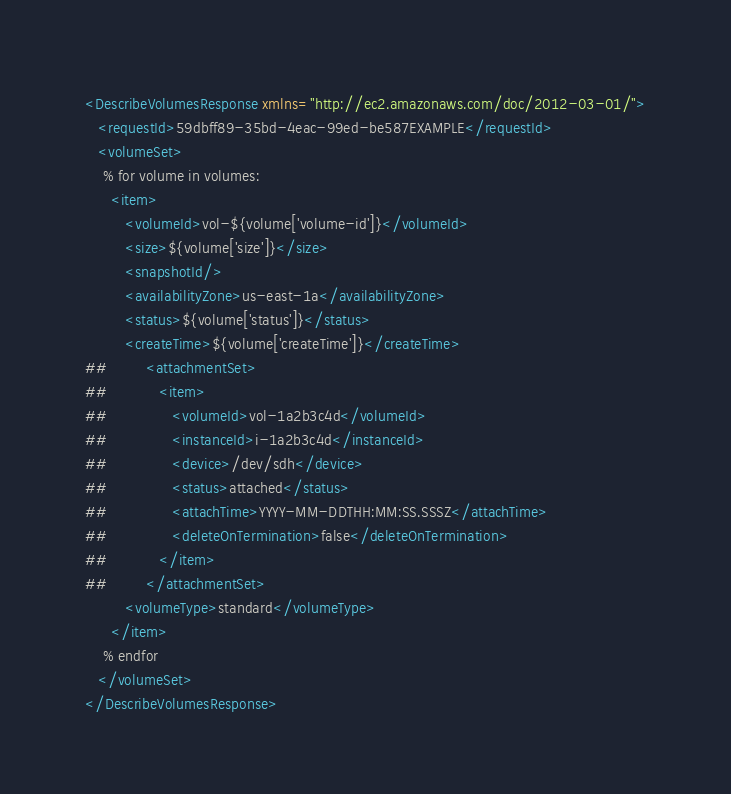<code> <loc_0><loc_0><loc_500><loc_500><_XML_><DescribeVolumesResponse xmlns="http://ec2.amazonaws.com/doc/2012-03-01/">
   <requestId>59dbff89-35bd-4eac-99ed-be587EXAMPLE</requestId>
   <volumeSet>
    % for volume in volumes:
      <item>
         <volumeId>vol-${volume['volume-id']}</volumeId>
         <size>${volume['size']}</size>
         <snapshotId/>
         <availabilityZone>us-east-1a</availabilityZone>
         <status>${volume['status']}</status>
         <createTime>${volume['createTime']}</createTime>
##         <attachmentSet>
##            <item>
##               <volumeId>vol-1a2b3c4d</volumeId>
##               <instanceId>i-1a2b3c4d</instanceId>
##               <device>/dev/sdh</device>
##               <status>attached</status>
##               <attachTime>YYYY-MM-DDTHH:MM:SS.SSSZ</attachTime>
##               <deleteOnTermination>false</deleteOnTermination>
##            </item>
##         </attachmentSet>
         <volumeType>standard</volumeType>
      </item>
    % endfor
   </volumeSet>
</DescribeVolumesResponse></code> 